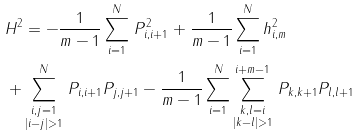Convert formula to latex. <formula><loc_0><loc_0><loc_500><loc_500>& H ^ { 2 } = - \frac { 1 } { m - 1 } \sum _ { i = 1 } ^ { N } \, P _ { i , i + 1 } ^ { 2 } + \frac { 1 } { m - 1 } \sum _ { i = 1 } ^ { N } h _ { i , m } ^ { 2 } \\ & + \sum _ { \substack { i , j = 1 \\ | i - j | > 1 } } ^ { N } \, P _ { i , i + 1 } P _ { j , j + 1 } - \frac { 1 } { m - 1 } \sum _ { i = 1 } ^ { N } \sum _ { \substack { k , l = i \\ | k - l | > 1 } } ^ { i + m - 1 } \, P _ { k , k + 1 } P _ { l , l + 1 }</formula> 